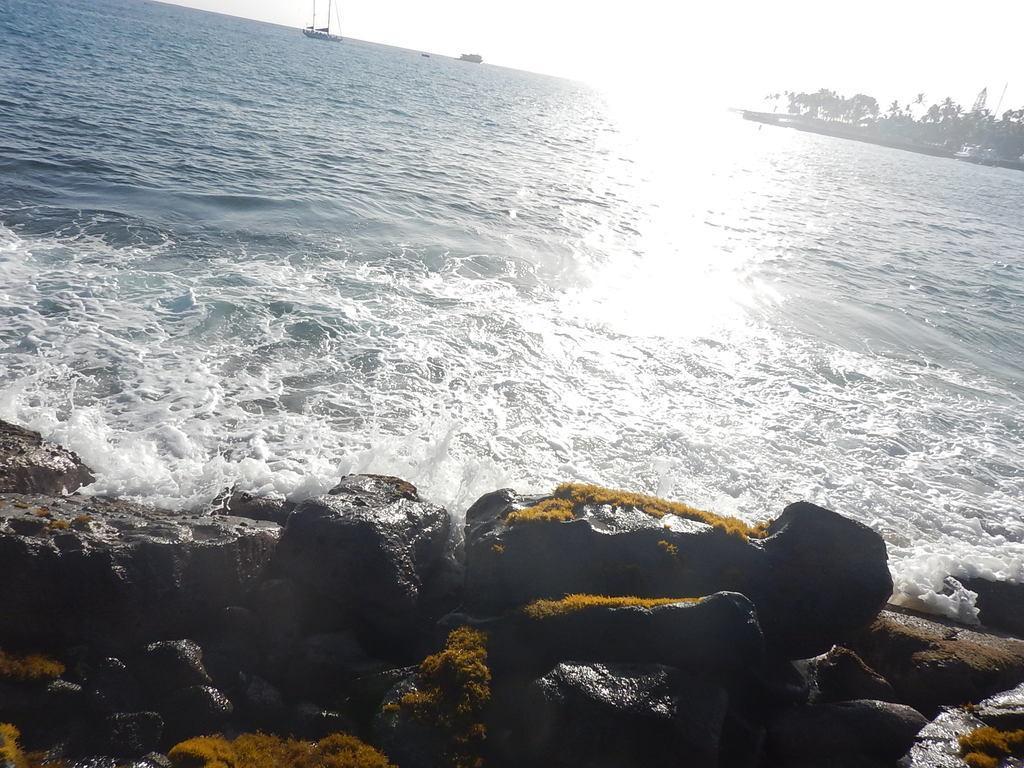Could you give a brief overview of what you see in this image? In this image we can see the boats on the water, there are some rocks and trees, in the background we can see the sky. 